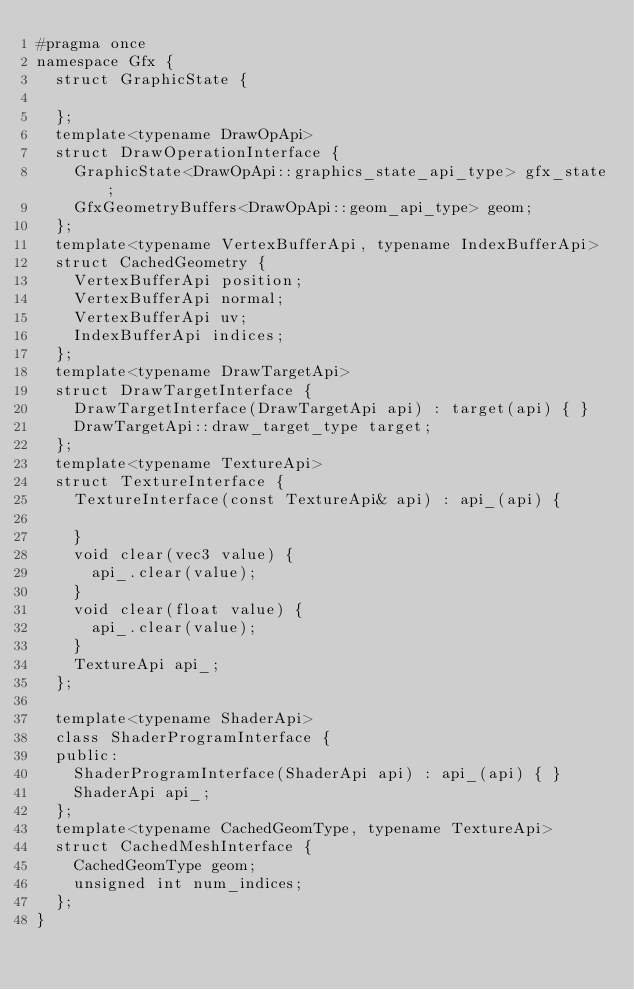Convert code to text. <code><loc_0><loc_0><loc_500><loc_500><_C_>#pragma once
namespace Gfx {
	struct GraphicState {

	};
	template<typename DrawOpApi>
	struct DrawOperationInterface {
		GraphicState<DrawOpApi::graphics_state_api_type> gfx_state;
		GfxGeometryBuffers<DrawOpApi::geom_api_type> geom;
	};
	template<typename VertexBufferApi, typename IndexBufferApi>
	struct CachedGeometry {
		VertexBufferApi position;
		VertexBufferApi normal;
		VertexBufferApi uv;
		IndexBufferApi indices;
	};
	template<typename DrawTargetApi>
	struct DrawTargetInterface {
		DrawTargetInterface(DrawTargetApi api) : target(api) { }
		DrawTargetApi::draw_target_type target;
	};
	template<typename TextureApi>
	struct TextureInterface {
		TextureInterface(const TextureApi& api) : api_(api) {

		}
		void clear(vec3 value) {
			api_.clear(value);
		}
		void clear(float value) {
			api_.clear(value);
		}
		TextureApi api_;
	};

	template<typename ShaderApi>
	class ShaderProgramInterface {
	public:
		ShaderProgramInterface(ShaderApi api) : api_(api) { }
		ShaderApi api_;
	};
	template<typename CachedGeomType, typename TextureApi>
	struct CachedMeshInterface {
		CachedGeomType geom;
		unsigned int num_indices;
	};
}</code> 